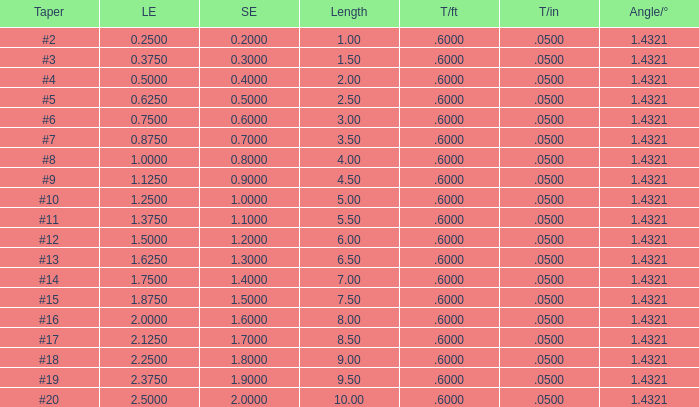Which Angle from center/° has a Taper/ft smaller than 0.6000000000000001? 19.0. 